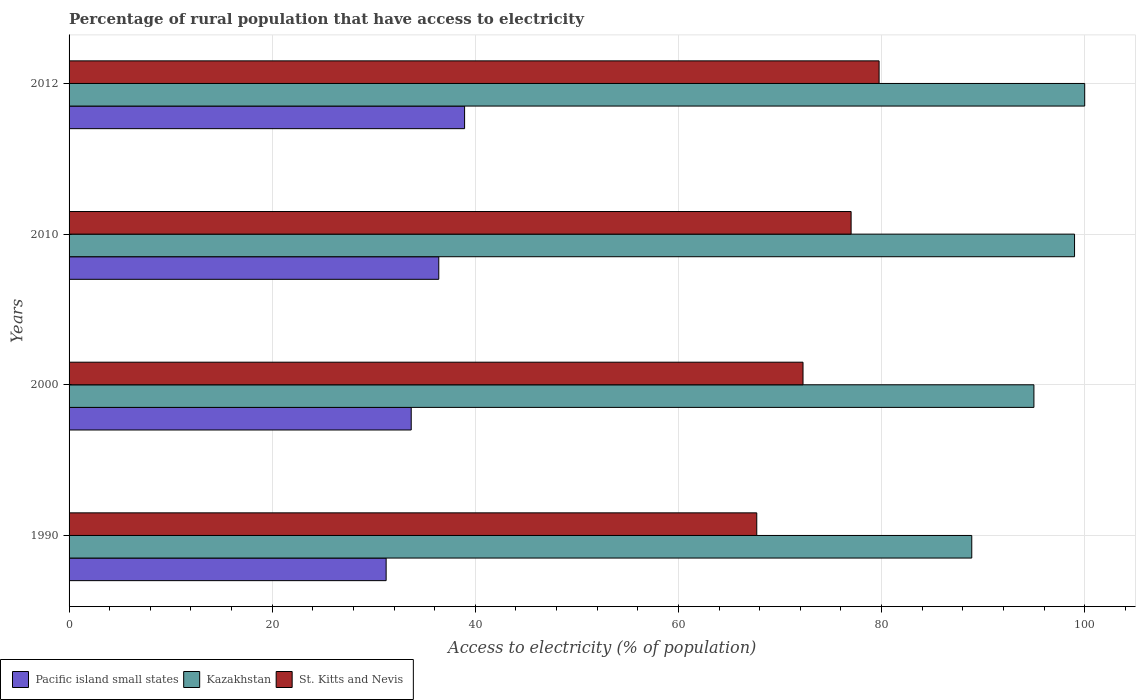How many different coloured bars are there?
Keep it short and to the point. 3. Are the number of bars per tick equal to the number of legend labels?
Provide a short and direct response. Yes. What is the label of the 2nd group of bars from the top?
Your answer should be very brief. 2010. In how many cases, is the number of bars for a given year not equal to the number of legend labels?
Make the answer very short. 0. What is the percentage of rural population that have access to electricity in Pacific island small states in 2010?
Offer a very short reply. 36.4. Across all years, what is the minimum percentage of rural population that have access to electricity in Kazakhstan?
Keep it short and to the point. 88.88. In which year was the percentage of rural population that have access to electricity in Kazakhstan maximum?
Give a very brief answer. 2012. In which year was the percentage of rural population that have access to electricity in Kazakhstan minimum?
Your response must be concise. 1990. What is the total percentage of rural population that have access to electricity in Kazakhstan in the graph?
Your response must be concise. 382.88. What is the difference between the percentage of rural population that have access to electricity in Pacific island small states in 2000 and that in 2010?
Offer a very short reply. -2.71. What is the difference between the percentage of rural population that have access to electricity in Kazakhstan in 1990 and the percentage of rural population that have access to electricity in St. Kitts and Nevis in 2010?
Make the answer very short. 11.88. What is the average percentage of rural population that have access to electricity in Kazakhstan per year?
Provide a short and direct response. 95.72. In the year 1990, what is the difference between the percentage of rural population that have access to electricity in Pacific island small states and percentage of rural population that have access to electricity in Kazakhstan?
Keep it short and to the point. -57.66. In how many years, is the percentage of rural population that have access to electricity in Pacific island small states greater than 32 %?
Provide a short and direct response. 3. What is the ratio of the percentage of rural population that have access to electricity in Pacific island small states in 1990 to that in 2000?
Your answer should be very brief. 0.93. What is the difference between the highest and the second highest percentage of rural population that have access to electricity in Kazakhstan?
Your answer should be compact. 1. What is the difference between the highest and the lowest percentage of rural population that have access to electricity in Kazakhstan?
Ensure brevity in your answer.  11.12. In how many years, is the percentage of rural population that have access to electricity in St. Kitts and Nevis greater than the average percentage of rural population that have access to electricity in St. Kitts and Nevis taken over all years?
Offer a very short reply. 2. Is the sum of the percentage of rural population that have access to electricity in Pacific island small states in 2000 and 2012 greater than the maximum percentage of rural population that have access to electricity in Kazakhstan across all years?
Your answer should be compact. No. What does the 3rd bar from the top in 1990 represents?
Ensure brevity in your answer.  Pacific island small states. What does the 2nd bar from the bottom in 2012 represents?
Ensure brevity in your answer.  Kazakhstan. Is it the case that in every year, the sum of the percentage of rural population that have access to electricity in St. Kitts and Nevis and percentage of rural population that have access to electricity in Kazakhstan is greater than the percentage of rural population that have access to electricity in Pacific island small states?
Give a very brief answer. Yes. Are all the bars in the graph horizontal?
Your answer should be very brief. Yes. How many years are there in the graph?
Your answer should be compact. 4. How are the legend labels stacked?
Ensure brevity in your answer.  Horizontal. What is the title of the graph?
Your response must be concise. Percentage of rural population that have access to electricity. What is the label or title of the X-axis?
Make the answer very short. Access to electricity (% of population). What is the Access to electricity (% of population) in Pacific island small states in 1990?
Provide a succinct answer. 31.22. What is the Access to electricity (% of population) in Kazakhstan in 1990?
Provide a short and direct response. 88.88. What is the Access to electricity (% of population) in St. Kitts and Nevis in 1990?
Your answer should be very brief. 67.71. What is the Access to electricity (% of population) in Pacific island small states in 2000?
Your response must be concise. 33.69. What is the Access to electricity (% of population) of St. Kitts and Nevis in 2000?
Make the answer very short. 72.27. What is the Access to electricity (% of population) of Pacific island small states in 2010?
Give a very brief answer. 36.4. What is the Access to electricity (% of population) of Pacific island small states in 2012?
Give a very brief answer. 38.94. What is the Access to electricity (% of population) in Kazakhstan in 2012?
Give a very brief answer. 100. What is the Access to electricity (% of population) of St. Kitts and Nevis in 2012?
Ensure brevity in your answer.  79.75. Across all years, what is the maximum Access to electricity (% of population) of Pacific island small states?
Your answer should be compact. 38.94. Across all years, what is the maximum Access to electricity (% of population) in Kazakhstan?
Make the answer very short. 100. Across all years, what is the maximum Access to electricity (% of population) in St. Kitts and Nevis?
Offer a very short reply. 79.75. Across all years, what is the minimum Access to electricity (% of population) of Pacific island small states?
Keep it short and to the point. 31.22. Across all years, what is the minimum Access to electricity (% of population) of Kazakhstan?
Your response must be concise. 88.88. Across all years, what is the minimum Access to electricity (% of population) of St. Kitts and Nevis?
Make the answer very short. 67.71. What is the total Access to electricity (% of population) of Pacific island small states in the graph?
Provide a succinct answer. 140.25. What is the total Access to electricity (% of population) of Kazakhstan in the graph?
Provide a short and direct response. 382.88. What is the total Access to electricity (% of population) in St. Kitts and Nevis in the graph?
Your answer should be compact. 296.73. What is the difference between the Access to electricity (% of population) in Pacific island small states in 1990 and that in 2000?
Provide a short and direct response. -2.47. What is the difference between the Access to electricity (% of population) in Kazakhstan in 1990 and that in 2000?
Your answer should be compact. -6.12. What is the difference between the Access to electricity (% of population) of St. Kitts and Nevis in 1990 and that in 2000?
Keep it short and to the point. -4.55. What is the difference between the Access to electricity (% of population) in Pacific island small states in 1990 and that in 2010?
Your response must be concise. -5.18. What is the difference between the Access to electricity (% of population) in Kazakhstan in 1990 and that in 2010?
Keep it short and to the point. -10.12. What is the difference between the Access to electricity (% of population) of St. Kitts and Nevis in 1990 and that in 2010?
Your answer should be very brief. -9.29. What is the difference between the Access to electricity (% of population) in Pacific island small states in 1990 and that in 2012?
Your response must be concise. -7.73. What is the difference between the Access to electricity (% of population) of Kazakhstan in 1990 and that in 2012?
Your answer should be compact. -11.12. What is the difference between the Access to electricity (% of population) of St. Kitts and Nevis in 1990 and that in 2012?
Make the answer very short. -12.04. What is the difference between the Access to electricity (% of population) of Pacific island small states in 2000 and that in 2010?
Offer a very short reply. -2.71. What is the difference between the Access to electricity (% of population) in St. Kitts and Nevis in 2000 and that in 2010?
Your response must be concise. -4.74. What is the difference between the Access to electricity (% of population) of Pacific island small states in 2000 and that in 2012?
Give a very brief answer. -5.26. What is the difference between the Access to electricity (% of population) of St. Kitts and Nevis in 2000 and that in 2012?
Make the answer very short. -7.49. What is the difference between the Access to electricity (% of population) in Pacific island small states in 2010 and that in 2012?
Keep it short and to the point. -2.54. What is the difference between the Access to electricity (% of population) of Kazakhstan in 2010 and that in 2012?
Your answer should be compact. -1. What is the difference between the Access to electricity (% of population) in St. Kitts and Nevis in 2010 and that in 2012?
Give a very brief answer. -2.75. What is the difference between the Access to electricity (% of population) of Pacific island small states in 1990 and the Access to electricity (% of population) of Kazakhstan in 2000?
Offer a terse response. -63.78. What is the difference between the Access to electricity (% of population) in Pacific island small states in 1990 and the Access to electricity (% of population) in St. Kitts and Nevis in 2000?
Keep it short and to the point. -41.05. What is the difference between the Access to electricity (% of population) in Kazakhstan in 1990 and the Access to electricity (% of population) in St. Kitts and Nevis in 2000?
Your answer should be very brief. 16.61. What is the difference between the Access to electricity (% of population) of Pacific island small states in 1990 and the Access to electricity (% of population) of Kazakhstan in 2010?
Provide a succinct answer. -67.78. What is the difference between the Access to electricity (% of population) of Pacific island small states in 1990 and the Access to electricity (% of population) of St. Kitts and Nevis in 2010?
Provide a succinct answer. -45.78. What is the difference between the Access to electricity (% of population) of Kazakhstan in 1990 and the Access to electricity (% of population) of St. Kitts and Nevis in 2010?
Make the answer very short. 11.88. What is the difference between the Access to electricity (% of population) of Pacific island small states in 1990 and the Access to electricity (% of population) of Kazakhstan in 2012?
Your answer should be compact. -68.78. What is the difference between the Access to electricity (% of population) of Pacific island small states in 1990 and the Access to electricity (% of population) of St. Kitts and Nevis in 2012?
Ensure brevity in your answer.  -48.54. What is the difference between the Access to electricity (% of population) of Kazakhstan in 1990 and the Access to electricity (% of population) of St. Kitts and Nevis in 2012?
Make the answer very short. 9.12. What is the difference between the Access to electricity (% of population) of Pacific island small states in 2000 and the Access to electricity (% of population) of Kazakhstan in 2010?
Provide a short and direct response. -65.31. What is the difference between the Access to electricity (% of population) of Pacific island small states in 2000 and the Access to electricity (% of population) of St. Kitts and Nevis in 2010?
Provide a succinct answer. -43.31. What is the difference between the Access to electricity (% of population) in Kazakhstan in 2000 and the Access to electricity (% of population) in St. Kitts and Nevis in 2010?
Your response must be concise. 18. What is the difference between the Access to electricity (% of population) of Pacific island small states in 2000 and the Access to electricity (% of population) of Kazakhstan in 2012?
Your answer should be very brief. -66.31. What is the difference between the Access to electricity (% of population) in Pacific island small states in 2000 and the Access to electricity (% of population) in St. Kitts and Nevis in 2012?
Your response must be concise. -46.07. What is the difference between the Access to electricity (% of population) of Kazakhstan in 2000 and the Access to electricity (% of population) of St. Kitts and Nevis in 2012?
Give a very brief answer. 15.25. What is the difference between the Access to electricity (% of population) in Pacific island small states in 2010 and the Access to electricity (% of population) in Kazakhstan in 2012?
Your response must be concise. -63.6. What is the difference between the Access to electricity (% of population) of Pacific island small states in 2010 and the Access to electricity (% of population) of St. Kitts and Nevis in 2012?
Ensure brevity in your answer.  -43.35. What is the difference between the Access to electricity (% of population) of Kazakhstan in 2010 and the Access to electricity (% of population) of St. Kitts and Nevis in 2012?
Offer a very short reply. 19.25. What is the average Access to electricity (% of population) of Pacific island small states per year?
Offer a very short reply. 35.06. What is the average Access to electricity (% of population) of Kazakhstan per year?
Ensure brevity in your answer.  95.72. What is the average Access to electricity (% of population) in St. Kitts and Nevis per year?
Offer a very short reply. 74.18. In the year 1990, what is the difference between the Access to electricity (% of population) in Pacific island small states and Access to electricity (% of population) in Kazakhstan?
Your response must be concise. -57.66. In the year 1990, what is the difference between the Access to electricity (% of population) of Pacific island small states and Access to electricity (% of population) of St. Kitts and Nevis?
Your answer should be compact. -36.49. In the year 1990, what is the difference between the Access to electricity (% of population) in Kazakhstan and Access to electricity (% of population) in St. Kitts and Nevis?
Offer a terse response. 21.17. In the year 2000, what is the difference between the Access to electricity (% of population) of Pacific island small states and Access to electricity (% of population) of Kazakhstan?
Your answer should be very brief. -61.31. In the year 2000, what is the difference between the Access to electricity (% of population) in Pacific island small states and Access to electricity (% of population) in St. Kitts and Nevis?
Give a very brief answer. -38.58. In the year 2000, what is the difference between the Access to electricity (% of population) in Kazakhstan and Access to electricity (% of population) in St. Kitts and Nevis?
Provide a short and direct response. 22.73. In the year 2010, what is the difference between the Access to electricity (% of population) in Pacific island small states and Access to electricity (% of population) in Kazakhstan?
Offer a terse response. -62.6. In the year 2010, what is the difference between the Access to electricity (% of population) in Pacific island small states and Access to electricity (% of population) in St. Kitts and Nevis?
Your answer should be compact. -40.6. In the year 2010, what is the difference between the Access to electricity (% of population) in Kazakhstan and Access to electricity (% of population) in St. Kitts and Nevis?
Make the answer very short. 22. In the year 2012, what is the difference between the Access to electricity (% of population) in Pacific island small states and Access to electricity (% of population) in Kazakhstan?
Ensure brevity in your answer.  -61.06. In the year 2012, what is the difference between the Access to electricity (% of population) of Pacific island small states and Access to electricity (% of population) of St. Kitts and Nevis?
Offer a terse response. -40.81. In the year 2012, what is the difference between the Access to electricity (% of population) in Kazakhstan and Access to electricity (% of population) in St. Kitts and Nevis?
Offer a very short reply. 20.25. What is the ratio of the Access to electricity (% of population) in Pacific island small states in 1990 to that in 2000?
Provide a succinct answer. 0.93. What is the ratio of the Access to electricity (% of population) of Kazakhstan in 1990 to that in 2000?
Provide a succinct answer. 0.94. What is the ratio of the Access to electricity (% of population) of St. Kitts and Nevis in 1990 to that in 2000?
Your answer should be compact. 0.94. What is the ratio of the Access to electricity (% of population) of Pacific island small states in 1990 to that in 2010?
Make the answer very short. 0.86. What is the ratio of the Access to electricity (% of population) in Kazakhstan in 1990 to that in 2010?
Give a very brief answer. 0.9. What is the ratio of the Access to electricity (% of population) of St. Kitts and Nevis in 1990 to that in 2010?
Ensure brevity in your answer.  0.88. What is the ratio of the Access to electricity (% of population) of Pacific island small states in 1990 to that in 2012?
Provide a succinct answer. 0.8. What is the ratio of the Access to electricity (% of population) in Kazakhstan in 1990 to that in 2012?
Make the answer very short. 0.89. What is the ratio of the Access to electricity (% of population) in St. Kitts and Nevis in 1990 to that in 2012?
Keep it short and to the point. 0.85. What is the ratio of the Access to electricity (% of population) in Pacific island small states in 2000 to that in 2010?
Offer a terse response. 0.93. What is the ratio of the Access to electricity (% of population) in Kazakhstan in 2000 to that in 2010?
Make the answer very short. 0.96. What is the ratio of the Access to electricity (% of population) in St. Kitts and Nevis in 2000 to that in 2010?
Your answer should be very brief. 0.94. What is the ratio of the Access to electricity (% of population) in Pacific island small states in 2000 to that in 2012?
Provide a short and direct response. 0.87. What is the ratio of the Access to electricity (% of population) in Kazakhstan in 2000 to that in 2012?
Make the answer very short. 0.95. What is the ratio of the Access to electricity (% of population) of St. Kitts and Nevis in 2000 to that in 2012?
Your answer should be very brief. 0.91. What is the ratio of the Access to electricity (% of population) of Pacific island small states in 2010 to that in 2012?
Offer a very short reply. 0.93. What is the ratio of the Access to electricity (% of population) of Kazakhstan in 2010 to that in 2012?
Provide a short and direct response. 0.99. What is the ratio of the Access to electricity (% of population) in St. Kitts and Nevis in 2010 to that in 2012?
Provide a short and direct response. 0.97. What is the difference between the highest and the second highest Access to electricity (% of population) of Pacific island small states?
Keep it short and to the point. 2.54. What is the difference between the highest and the second highest Access to electricity (% of population) of St. Kitts and Nevis?
Your response must be concise. 2.75. What is the difference between the highest and the lowest Access to electricity (% of population) of Pacific island small states?
Your response must be concise. 7.73. What is the difference between the highest and the lowest Access to electricity (% of population) in Kazakhstan?
Provide a short and direct response. 11.12. What is the difference between the highest and the lowest Access to electricity (% of population) in St. Kitts and Nevis?
Your answer should be very brief. 12.04. 